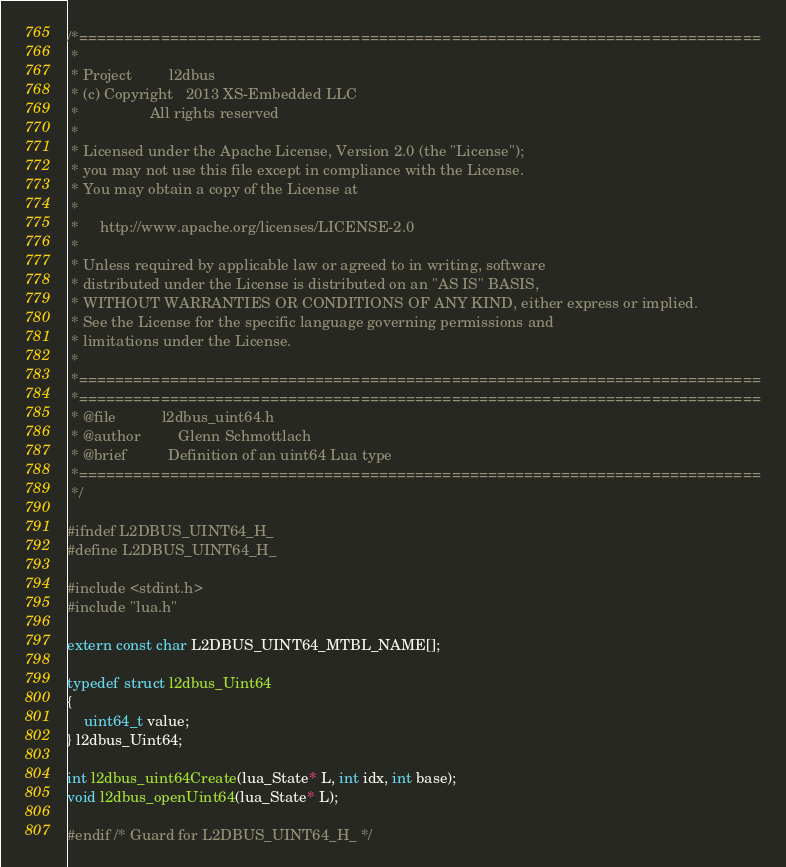Convert code to text. <code><loc_0><loc_0><loc_500><loc_500><_C_>/*===========================================================================
 * 
 * Project         l2dbus
 * (c) Copyright   2013 XS-Embedded LLC
 *                 All rights reserved
 *
 * Licensed under the Apache License, Version 2.0 (the "License");
 * you may not use this file except in compliance with the License.
 * You may obtain a copy of the License at
 *
 *     http://www.apache.org/licenses/LICENSE-2.0
 *
 * Unless required by applicable law or agreed to in writing, software
 * distributed under the License is distributed on an "AS IS" BASIS,
 * WITHOUT WARRANTIES OR CONDITIONS OF ANY KIND, either express or implied.
 * See the License for the specific language governing permissions and
 * limitations under the License.
 *
 *===========================================================================
 *===========================================================================
 * @file           l2dbus_uint64.h
 * @author         Glenn Schmottlach
 * @brief          Definition of an uint64 Lua type
 *===========================================================================
 */

#ifndef L2DBUS_UINT64_H_
#define L2DBUS_UINT64_H_

#include <stdint.h>
#include "lua.h"

extern const char L2DBUS_UINT64_MTBL_NAME[];

typedef struct l2dbus_Uint64
{
    uint64_t value;
} l2dbus_Uint64;

int l2dbus_uint64Create(lua_State* L, int idx, int base);
void l2dbus_openUint64(lua_State* L);

#endif /* Guard for L2DBUS_UINT64_H_ */
</code> 